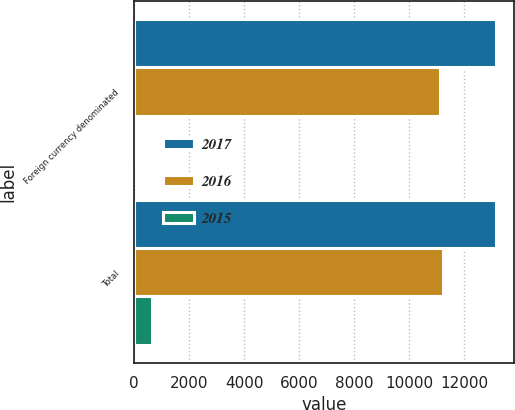Convert chart. <chart><loc_0><loc_0><loc_500><loc_500><stacked_bar_chart><ecel><fcel>Foreign currency denominated<fcel>Total<nl><fcel>2017<fcel>13147<fcel>13147<nl><fcel>2016<fcel>11113<fcel>11213<nl><fcel>2015<fcel>24<fcel>637<nl></chart> 